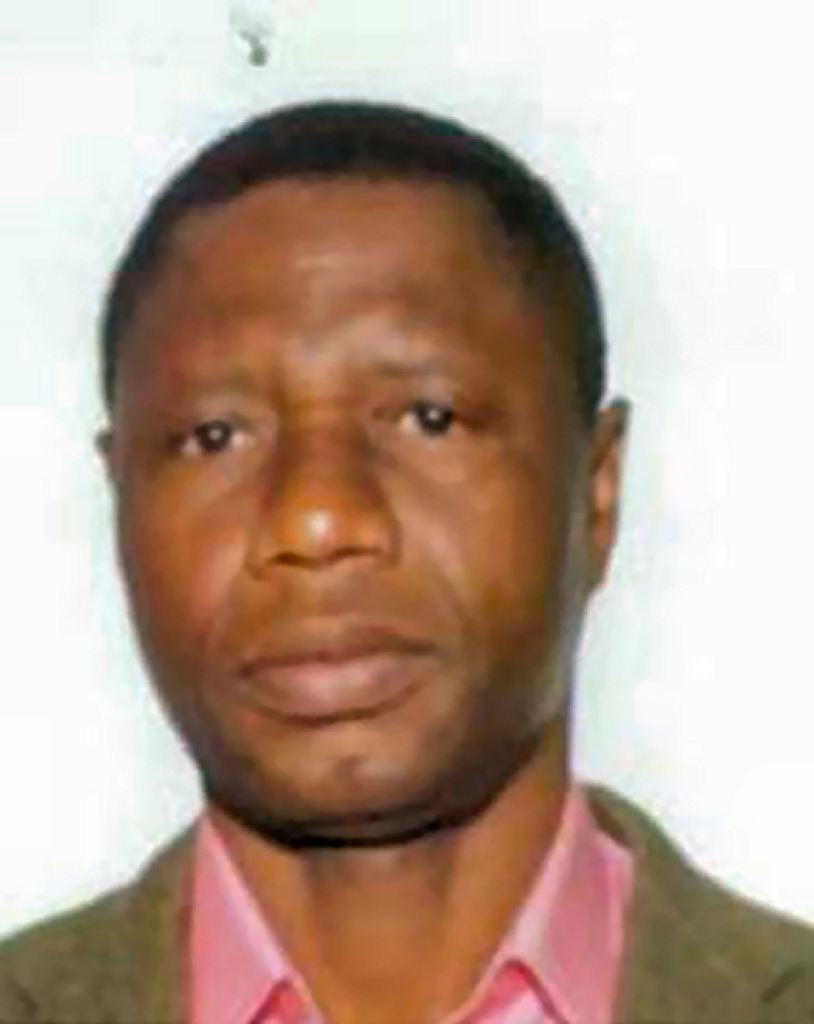Please provide a concise description of this image. This is a photograph of a man. 